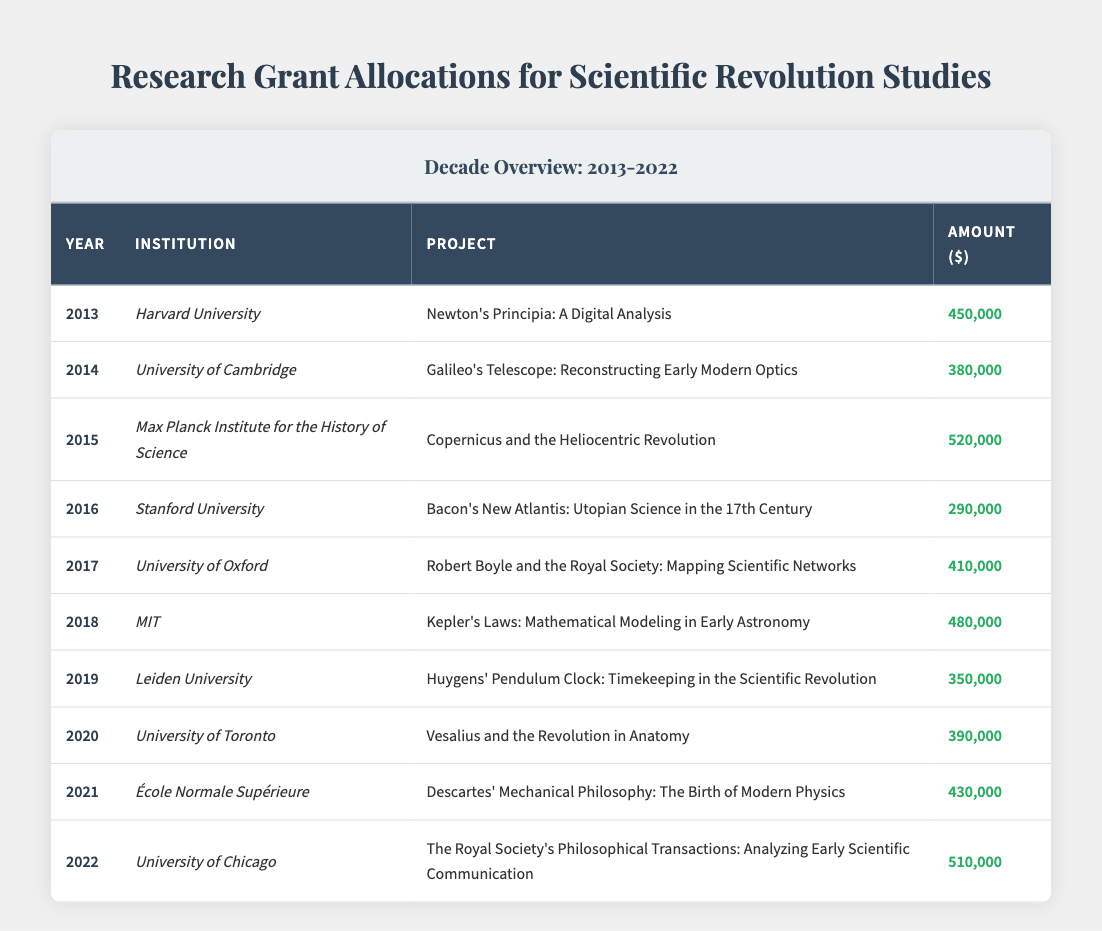What was the highest grant amount received in this decade? The highest grant amount can be identified by looking for the largest number in the "Amount" column. Scanning the amounts, 520,000 is the largest, which corresponds to the project "Copernicus and the Heliocentric Revolution" at the Max Planck Institute for the History of Science in 2015.
Answer: 520000 Which institution received a grant for a project in 2019? To answer this, I look at the year 2019 in the "Year" column. It shows that Leiden University received a grant for the project "Huygens' Pendulum Clock: Timekeeping in the Scientific Revolution" in that year.
Answer: Leiden University Did MIT receive more funding than University of Toronto in any year? MIT received 480,000 in 2018, while University of Toronto received 390,000 in 2020. Thus, MIT received more funding in 2018 compared to University of Toronto in 2020.
Answer: Yes What is the average grant amount from 2013 to 2022? First, I sum up all the grant amounts: 450,000 + 380,000 + 520,000 + 290,000 + 410,000 + 480,000 + 350,000 + 390,000 + 430,000 + 510,000 = 4,380,000. There are 10 projects, so the average is 4,380,000 divided by 10, which equals 438,000.
Answer: 438000 Was there a project focused specifically on Galileo, and if so, what was the year and amount? Yes, there is a project focused on Galileo; it is "Galileo's Telescope: Reconstructing Early Modern Optics," funded in 2014 with an amount of 380,000.
Answer: Yes, 2014, 380000 What is the total funding received by institutions in the years 2015 and 2016? First, identify the amounts for 2015 and 2016: in 2015, the amount was 520,000 (Max Planck Institute for the History of Science) and in 2016, it was 290,000 (Stanford University). Adding these gives 520,000 + 290,000 = 810,000.
Answer: 810000 Which two institutions received the lowest grant amounts, and what were those amounts? To find this, I look for the two smallest values in the "Amount" column. The smallest is 290,000 for Stanford University in 2016 and the second smallest is 350,000 for Leiden University in 2019.
Answer: Stanford University 290000, Leiden University 350000 In which year did the project about Descartes receive funding, and how much was it? I check the "Project" column for "Descartes' Mechanical Philosophy: The Birth of Modern Physics," which appears in the row for 2021. The amount listed for that project is 430,000.
Answer: 2021, 430000 